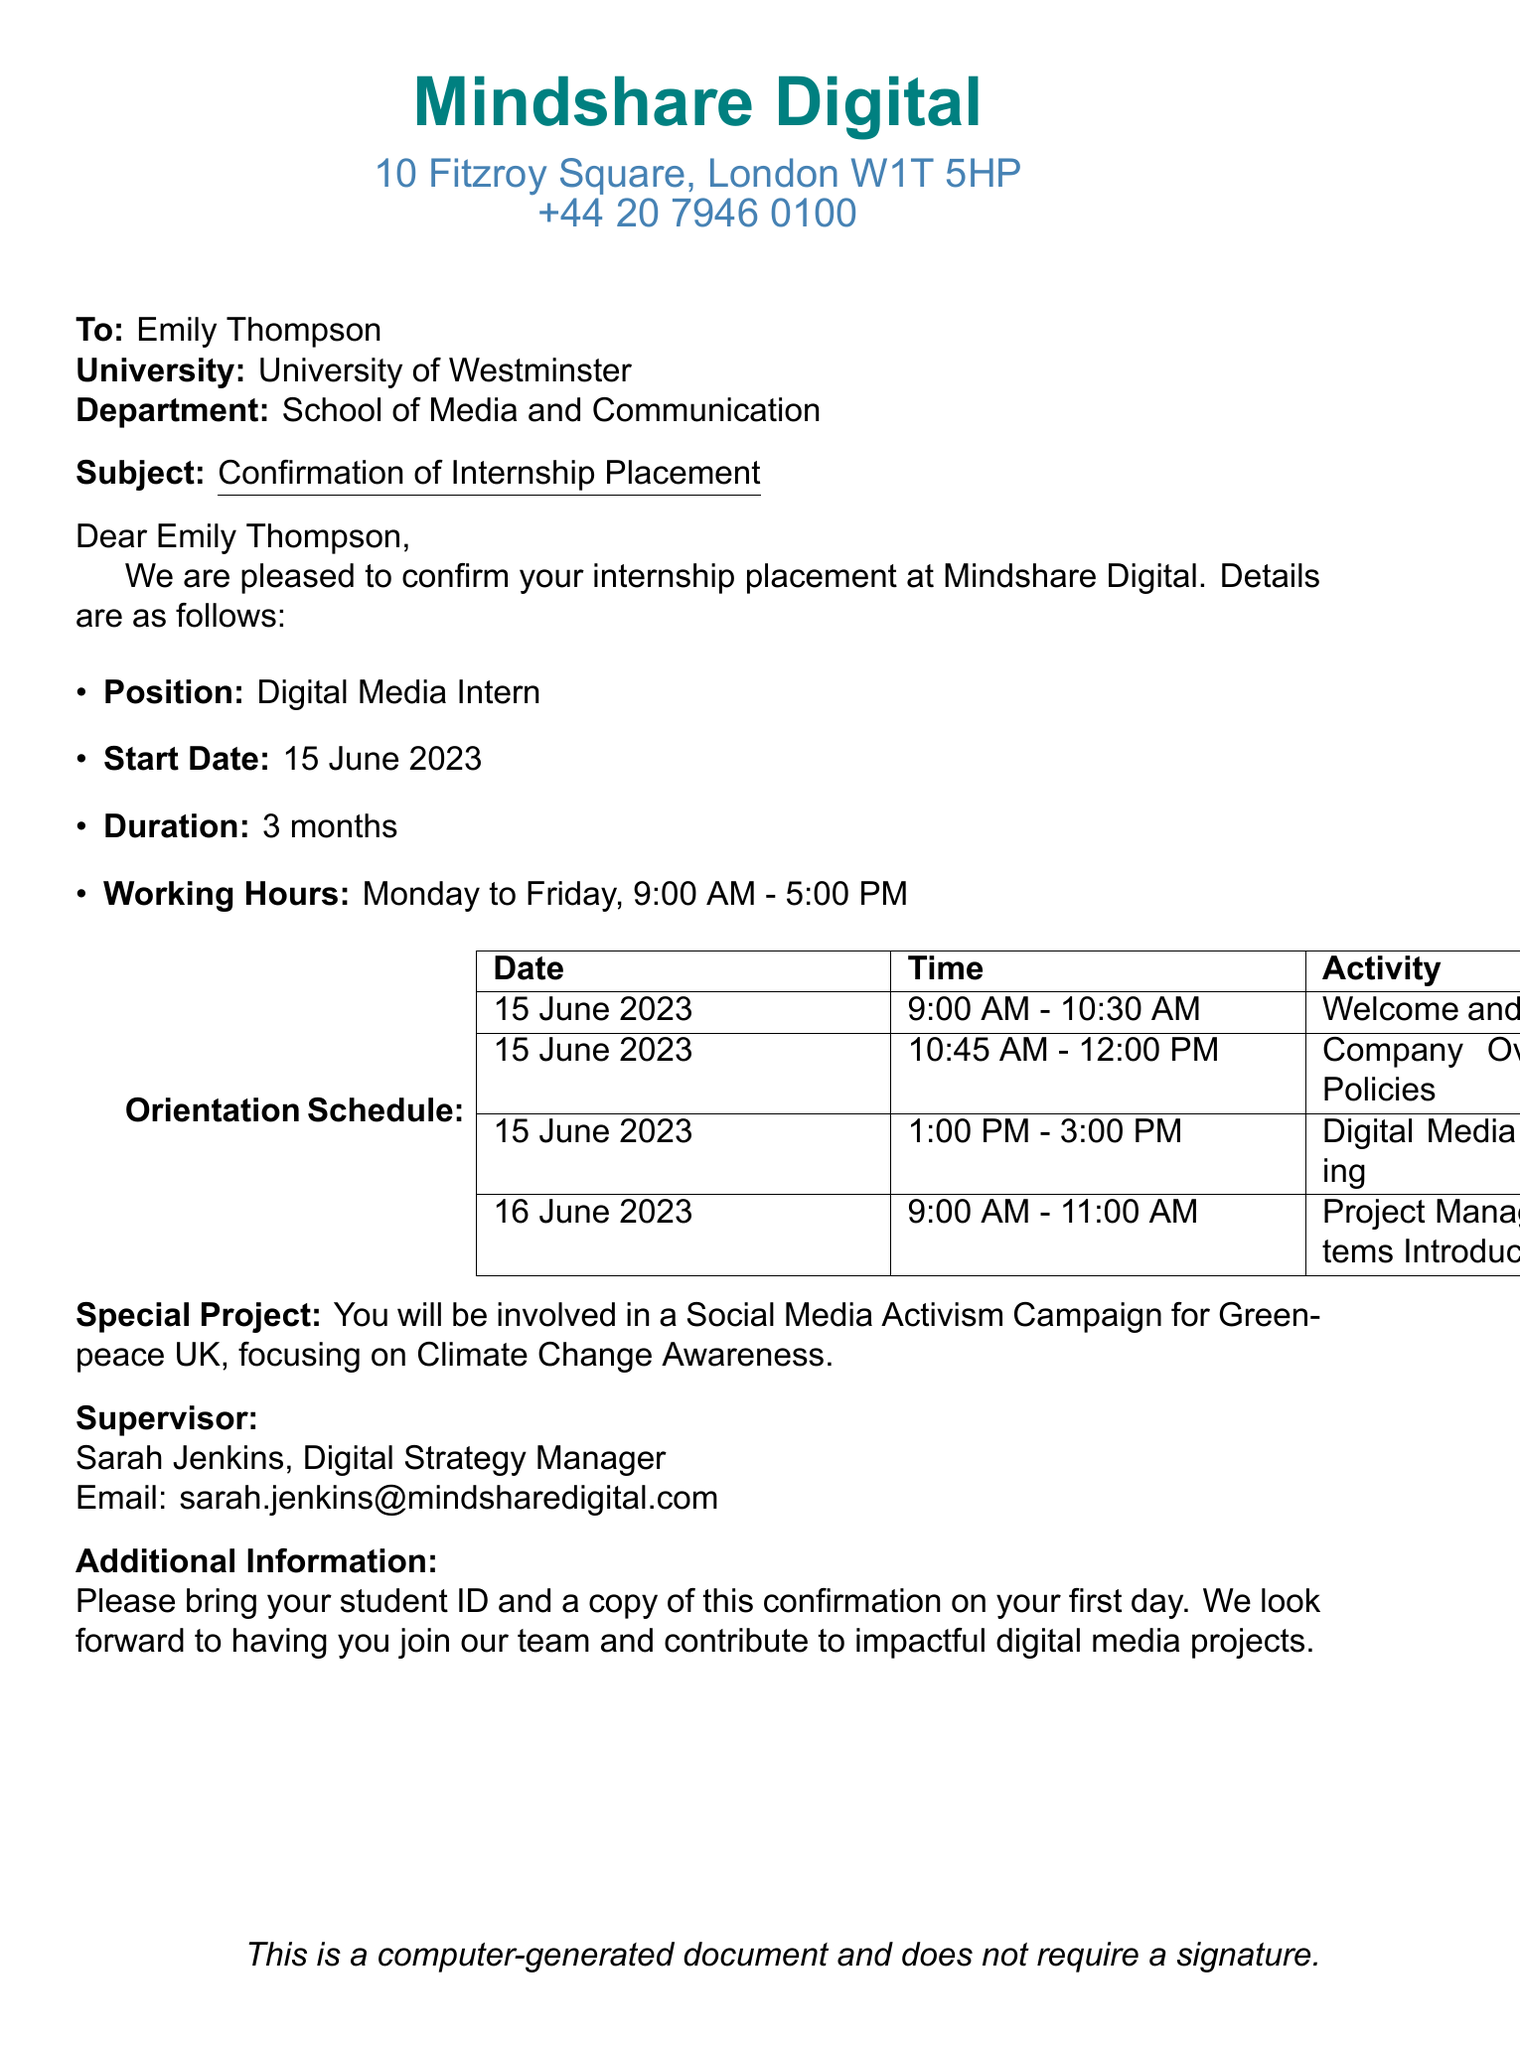What is the name of the digital media agency? The agency's name is mentioned at the top of the document.
Answer: Mindshare Digital What is the start date of the internship? The start date is listed in the details of the internship placement.
Answer: 15 June 2023 What is the duration of the internship? The duration is provided alongside other internship details in the document.
Answer: 3 months Who is the supervisor for the internship? The supervisor's name is stated towards the end of the document.
Answer: Sarah Jenkins What is the main focus of the special project? The special project's focus is described in the additional information section.
Answer: Social Media Activism Campaign for Greenpeace UK What are the working hours for the internship? The working hours are mentioned in the internship details.
Answer: 9:00 AM - 5:00 PM On what date does the orientation start? The orientation schedule begins on the same date as the start of the internship.
Answer: 15 June 2023 What activity is scheduled from 1:00 PM to 3:00 PM on the first day? The activity scheduled during that time slot is documented in the orientation schedule.
Answer: Digital Media Tools Training What should be brought on the first day? Additional information specifies what should be brought.
Answer: Student ID and a copy of this confirmation 